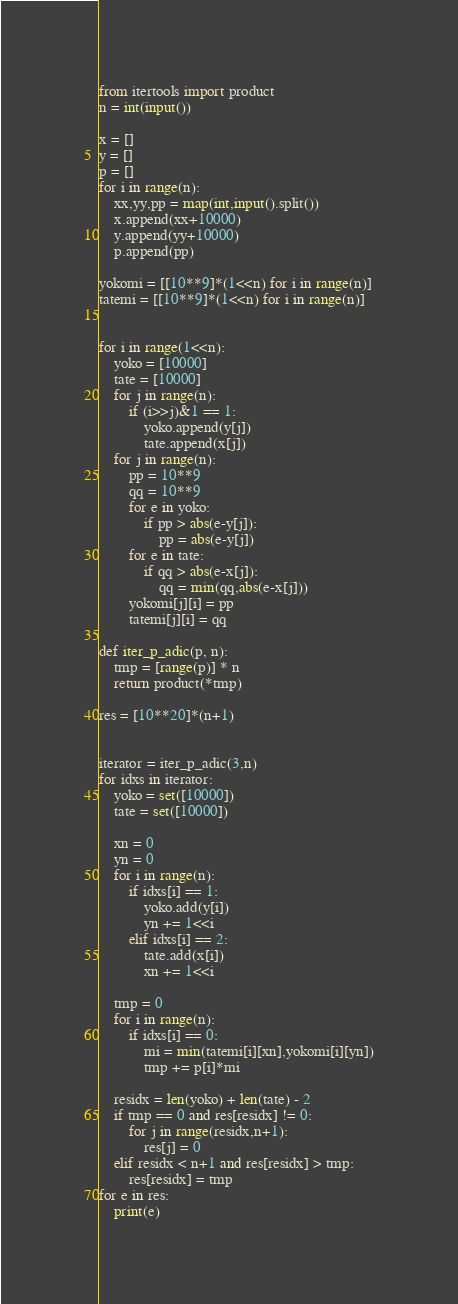<code> <loc_0><loc_0><loc_500><loc_500><_Python_>from itertools import product
n = int(input())

x = []
y = []
p = []
for i in range(n):
    xx,yy,pp = map(int,input().split())
    x.append(xx+10000)
    y.append(yy+10000)
    p.append(pp)

yokomi = [[10**9]*(1<<n) for i in range(n)]
tatemi = [[10**9]*(1<<n) for i in range(n)]


for i in range(1<<n):
    yoko = [10000]
    tate = [10000]
    for j in range(n):
        if (i>>j)&1 == 1:
            yoko.append(y[j])
            tate.append(x[j])
    for j in range(n):
        pp = 10**9
        qq = 10**9
        for e in yoko:
            if pp > abs(e-y[j]):
                pp = abs(e-y[j])
        for e in tate:
            if qq > abs(e-x[j]):
                qq = min(qq,abs(e-x[j]))
        yokomi[j][i] = pp
        tatemi[j][i] = qq

def iter_p_adic(p, n):
    tmp = [range(p)] * n
    return product(*tmp)

res = [10**20]*(n+1)


iterator = iter_p_adic(3,n)
for idxs in iterator:
    yoko = set([10000])
    tate = set([10000])
    
    xn = 0
    yn = 0
    for i in range(n):
        if idxs[i] == 1:
            yoko.add(y[i])
            yn += 1<<i
        elif idxs[i] == 2:
            tate.add(x[i])
            xn += 1<<i

    tmp = 0
    for i in range(n):
        if idxs[i] == 0:
            mi = min(tatemi[i][xn],yokomi[i][yn])
            tmp += p[i]*mi

    residx = len(yoko) + len(tate) - 2
    if tmp == 0 and res[residx] != 0:
        for j in range(residx,n+1):
            res[j] = 0
    elif residx < n+1 and res[residx] > tmp:
        res[residx] = tmp
for e in res:
    print(e)</code> 